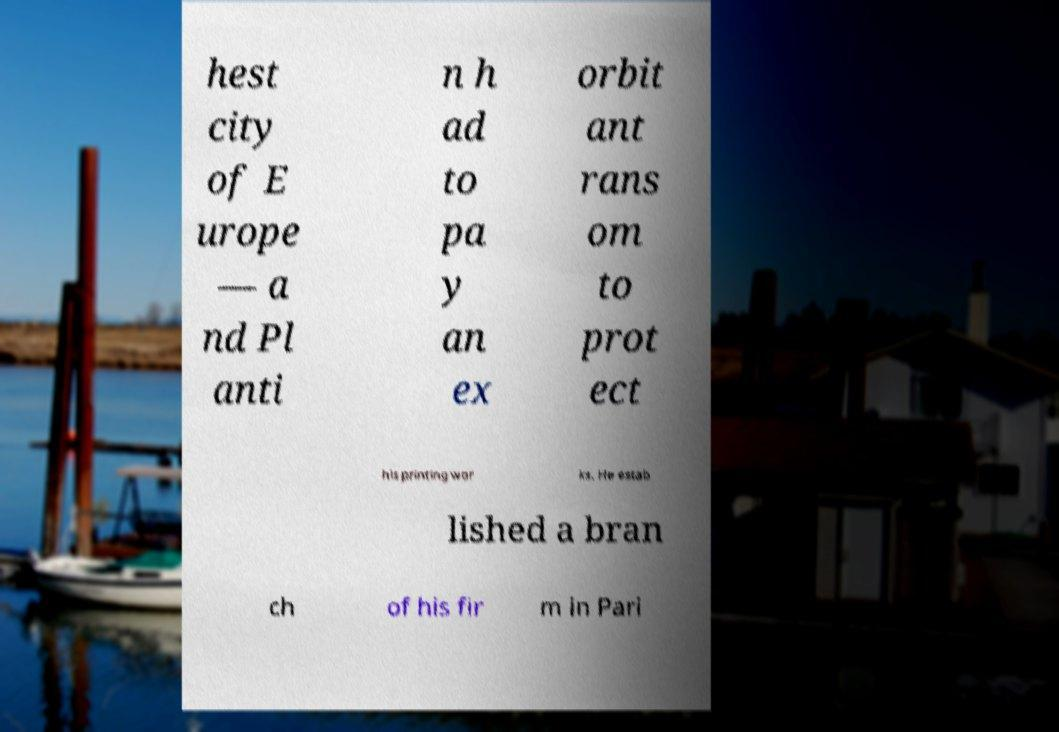For documentation purposes, I need the text within this image transcribed. Could you provide that? hest city of E urope — a nd Pl anti n h ad to pa y an ex orbit ant rans om to prot ect his printing wor ks. He estab lished a bran ch of his fir m in Pari 